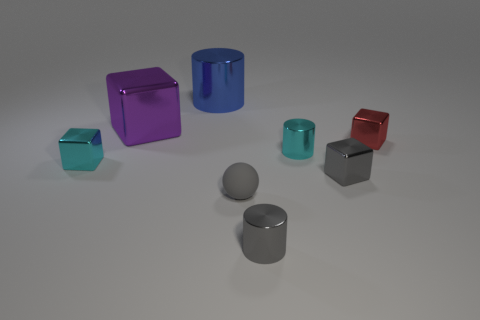Subtract all large cubes. How many cubes are left? 3 Add 2 rubber spheres. How many objects exist? 10 Subtract all gray cylinders. How many cylinders are left? 2 Subtract all gray balls. How many gray blocks are left? 1 Add 2 small gray metallic cubes. How many small gray metallic cubes are left? 3 Add 6 metallic blocks. How many metallic blocks exist? 10 Subtract 0 cyan balls. How many objects are left? 8 Subtract all balls. How many objects are left? 7 Subtract 2 cubes. How many cubes are left? 2 Subtract all green cylinders. Subtract all gray spheres. How many cylinders are left? 3 